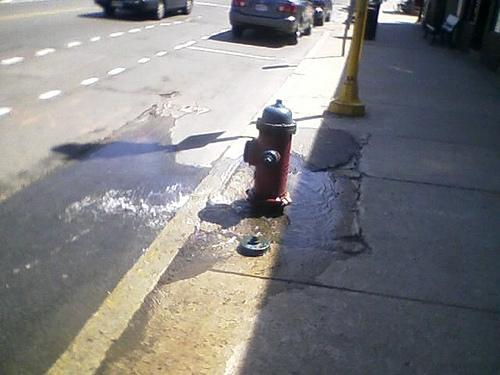How many different positions have been given for the fire hydrant and the leaking water? There are 5 positions for the fire hydrant and 4 positions for the leaking water. Provide a brief caption explaining the scene taking place in the image. Water is leaking from a red fire hydrant onto a city street, with a parked grey car and yellow sign post on the sidewalk. Explain the situation involving the fire hydrant in the image. Water is running from a red fire hydrant with a grey top, as the cap is off, causing a puddle on the road. Can you provide more information about the bench in the image? The bench is tucked in the shadows on the sidewalk and is positioned close to a garbage can In the multiple choice question below, choose the correct option about the fire hydrant. B. There is no cap on it Write a descriptive sentence about the grey car in a poetic style. Under the sun's shimmering embrace, the grey car rests by the curb, coexisting with the lively city street's disorder Do you find any indentation marks on the sidewalk? Yes, there are indentations in the sidewalk Find the object described as having a yellow base and being tall. The yellow sign post on the side of the road What color is the fire hydrant mentioned in the image? Red Decode the placement of objects in the diagram of the city street. Some objects include a red fire hydrant, yellow sign post on sidewalk, grey parked car, broken white lines on the street, and a bench on the sidewalk Identify the object described: white traffic lines painted on the road. The white markings in the center of the road Is any car driving in the street during the day? No, there are no cars driving in the street Come up with a short story using elements in the image. On a sunny day in the city, a passerby noticed a fire hydrant leaking water, creating a puddle on the road near a grey parked car. A bench sat on the sidewalk near a yellow sign post, waiting for someone to take a seat. Please transcribe the text found on the yellow sign post in the image. There is no text on the yellow sign post Describe the scene in the image, with more focus on the red fire hydrant and the water leak. A city street during daytime featuring a red fire hydrant with grey top, and water running from it onto the road, causing a puddle. What is happening with the fire hydrant? Water is running from the fire hydrant What activity is the grey car involved in? It is parked on the side of the road What is happening to the water on the street? The water is gathering in a puddle Describe the event involving the fire hydrant. Water is leaking from the fire hydrant, flooding the street Are there parked cars in the image? If yes, how many? Yes, there is one parked car in the image Which object in the image can you find next to the parked gray car at the curb? A yellow sign post on the side of the road 